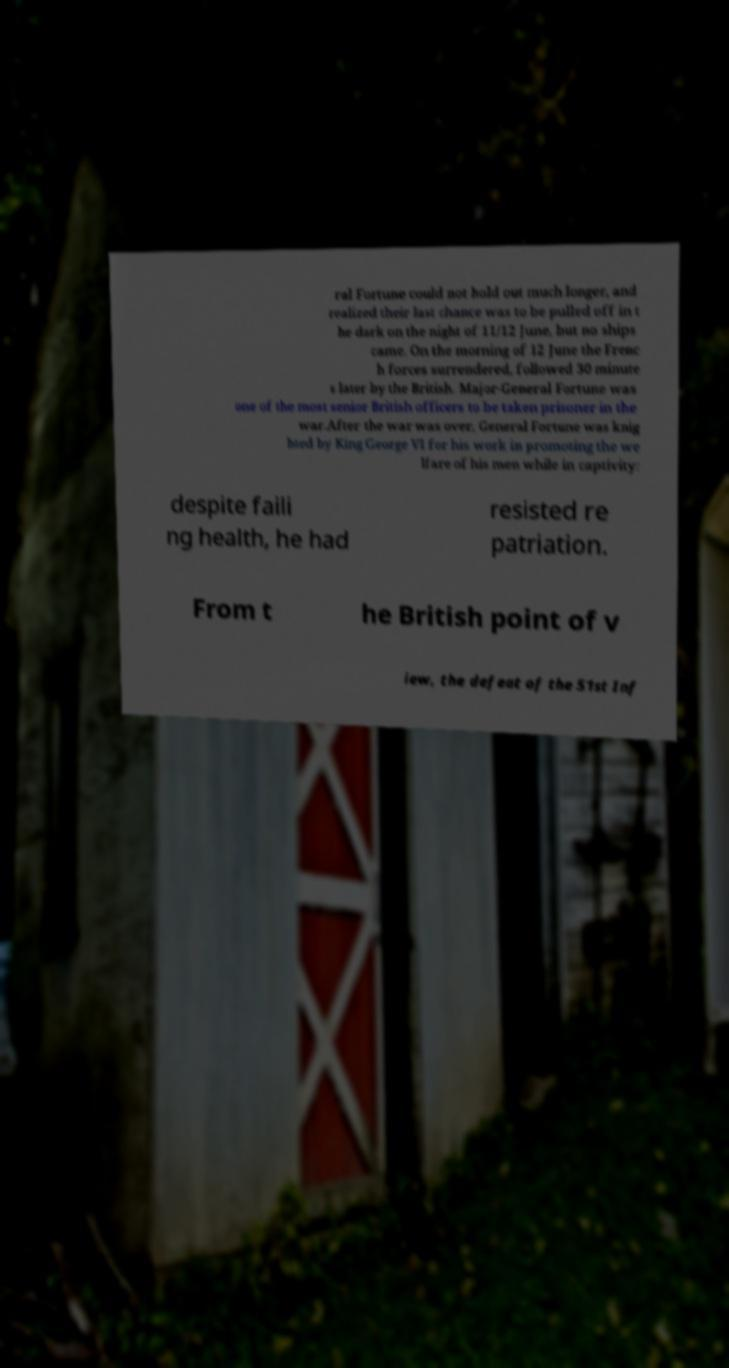I need the written content from this picture converted into text. Can you do that? ral Fortune could not hold out much longer, and realized their last chance was to be pulled off in t he dark on the night of 11/12 June, but no ships came. On the morning of 12 June the Frenc h forces surrendered, followed 30 minute s later by the British. Major-General Fortune was one of the most senior British officers to be taken prisoner in the war.After the war was over, General Fortune was knig hted by King George VI for his work in promoting the we lfare of his men while in captivity: despite faili ng health, he had resisted re patriation. From t he British point of v iew, the defeat of the 51st Inf 